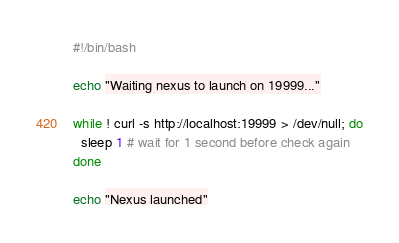Convert code to text. <code><loc_0><loc_0><loc_500><loc_500><_Bash_>#!/bin/bash

echo "Waiting nexus to launch on 19999..."

while ! curl -s http://localhost:19999 > /dev/null; do
  sleep 1 # wait for 1 second before check again
done

echo "Nexus launched"
</code> 